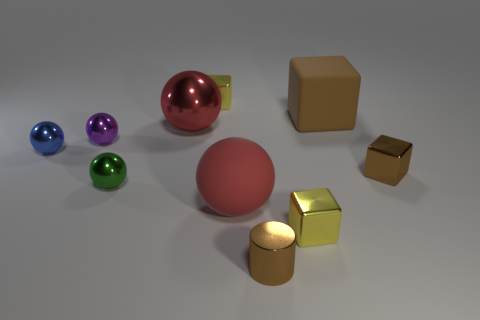The blue ball that is made of the same material as the brown cylinder is what size?
Your answer should be compact. Small. How many blocks are brown matte things or purple shiny things?
Ensure brevity in your answer.  1. Are there more tiny blue objects than large purple blocks?
Offer a very short reply. Yes. How many brown metallic cylinders have the same size as the matte cube?
Your response must be concise. 0. What shape is the large object that is the same color as the large rubber ball?
Give a very brief answer. Sphere. What number of objects are either red balls to the right of the red metallic ball or small green blocks?
Make the answer very short. 1. Are there fewer purple metal balls than tiny brown balls?
Your answer should be compact. No. There is a large red thing that is made of the same material as the tiny brown cylinder; what is its shape?
Offer a terse response. Sphere. There is a large brown thing; are there any purple objects right of it?
Give a very brief answer. No. Is the number of tiny cubes that are on the left side of the large brown cube less than the number of yellow blocks?
Your answer should be very brief. No. 